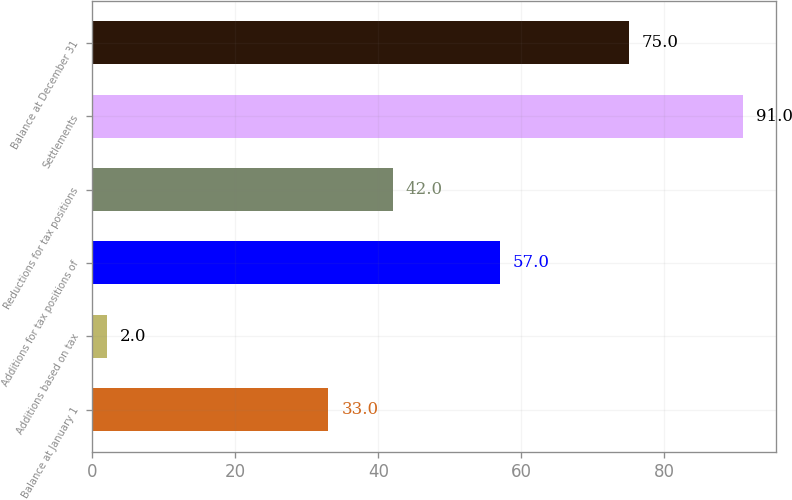Convert chart. <chart><loc_0><loc_0><loc_500><loc_500><bar_chart><fcel>Balance at January 1<fcel>Additions based on tax<fcel>Additions for tax positions of<fcel>Reductions for tax positions<fcel>Settlements<fcel>Balance at December 31<nl><fcel>33<fcel>2<fcel>57<fcel>42<fcel>91<fcel>75<nl></chart> 